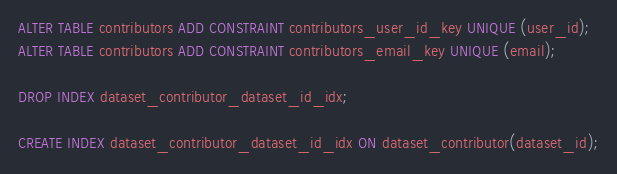Convert code to text. <code><loc_0><loc_0><loc_500><loc_500><_SQL_>ALTER TABLE contributors ADD CONSTRAINT contributors_user_id_key UNIQUE (user_id);
ALTER TABLE contributors ADD CONSTRAINT contributors_email_key UNIQUE (email);

DROP INDEX dataset_contributor_dataset_id_idx;

CREATE INDEX dataset_contributor_dataset_id_idx ON dataset_contributor(dataset_id);
</code> 